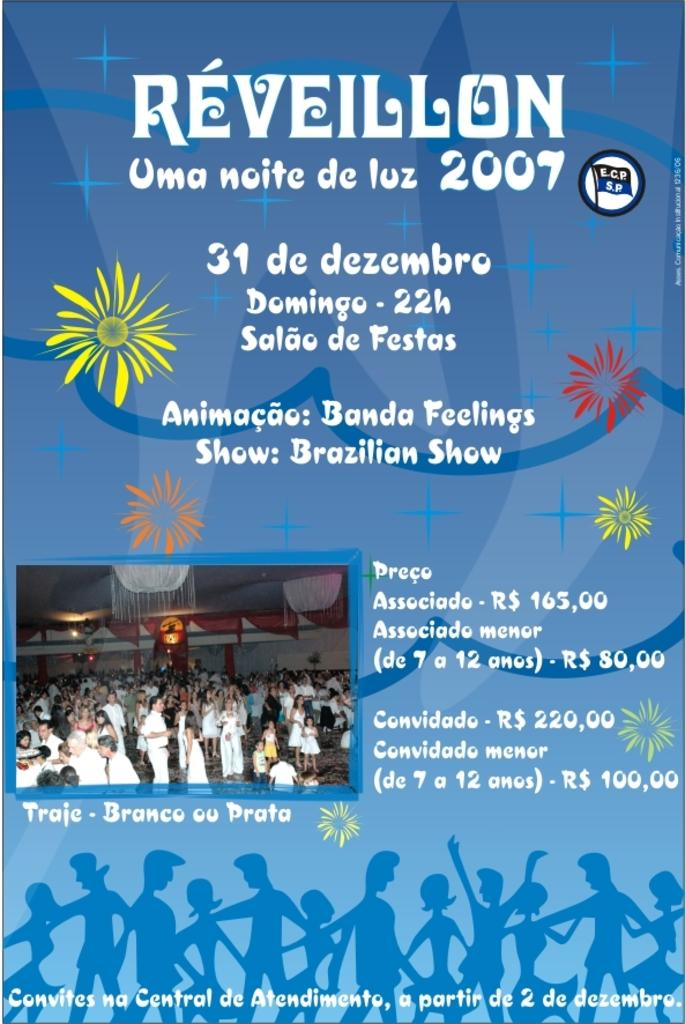<image>
Create a compact narrative representing the image presented. A poster with a picture and some text that is titled Reveillon. 